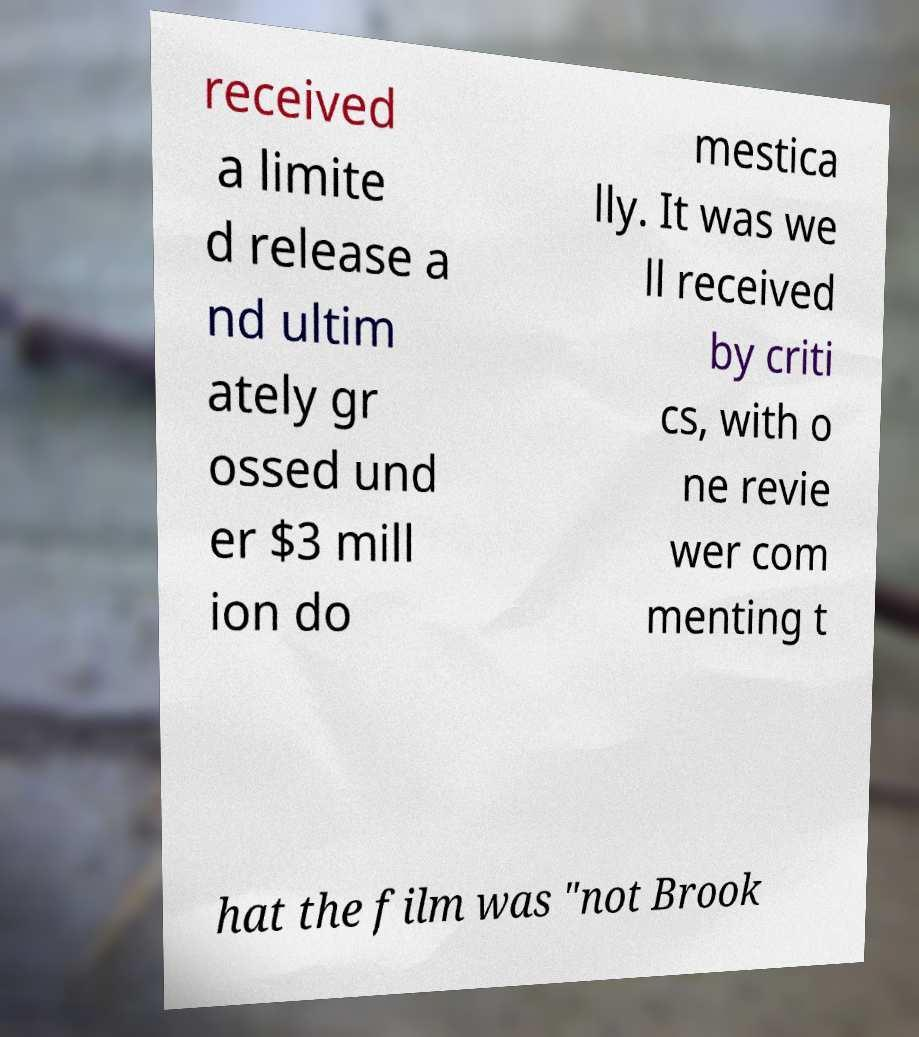Please read and relay the text visible in this image. What does it say? received a limite d release a nd ultim ately gr ossed und er $3 mill ion do mestica lly. It was we ll received by criti cs, with o ne revie wer com menting t hat the film was "not Brook 